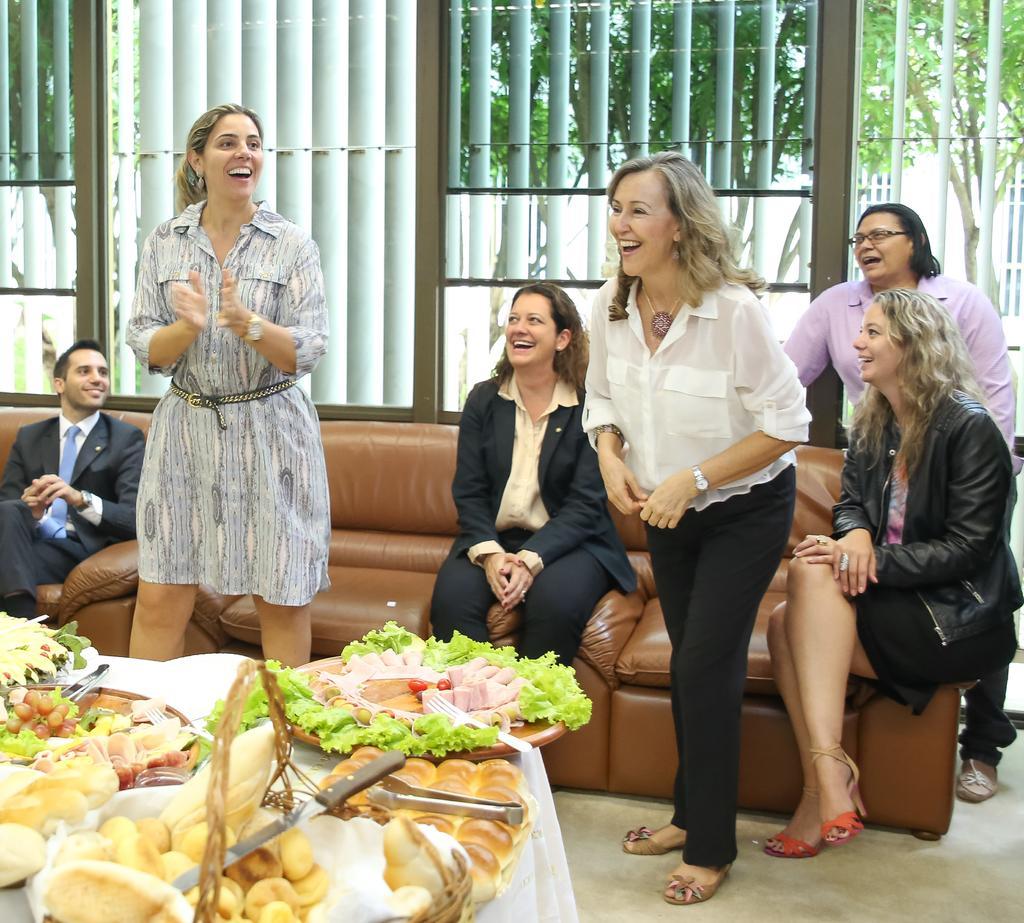In one or two sentences, can you explain what this image depicts? In this image I can see the group of people with different color dresses. I can see few people are sitting on the couches and few people are standing. In-front of these people I can see the plates and basket with some food items. These are on the table. In the background I can see many trees and the railing. 